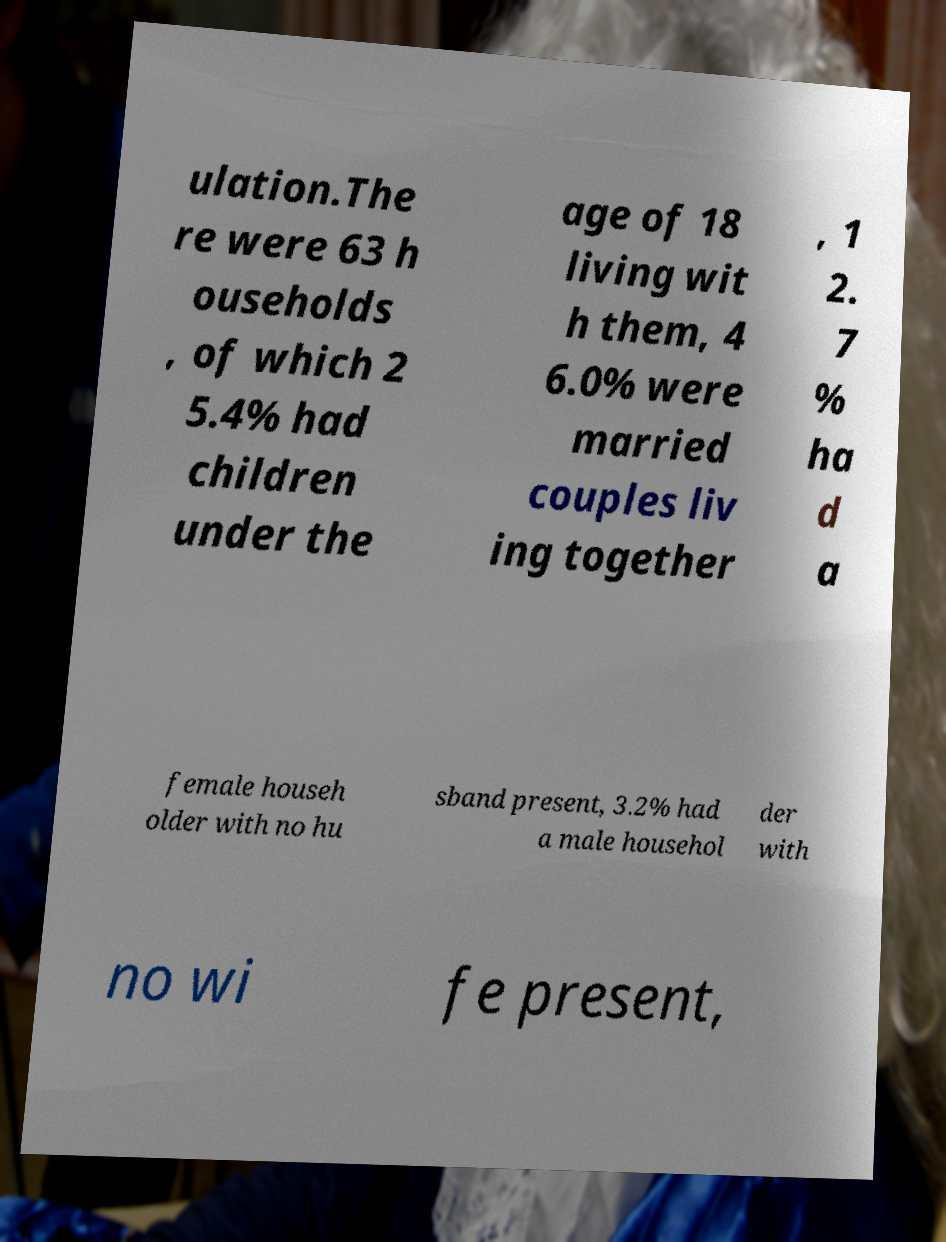Can you read and provide the text displayed in the image?This photo seems to have some interesting text. Can you extract and type it out for me? ulation.The re were 63 h ouseholds , of which 2 5.4% had children under the age of 18 living wit h them, 4 6.0% were married couples liv ing together , 1 2. 7 % ha d a female househ older with no hu sband present, 3.2% had a male househol der with no wi fe present, 